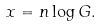Convert formula to latex. <formula><loc_0><loc_0><loc_500><loc_500>x = n \log G .</formula> 